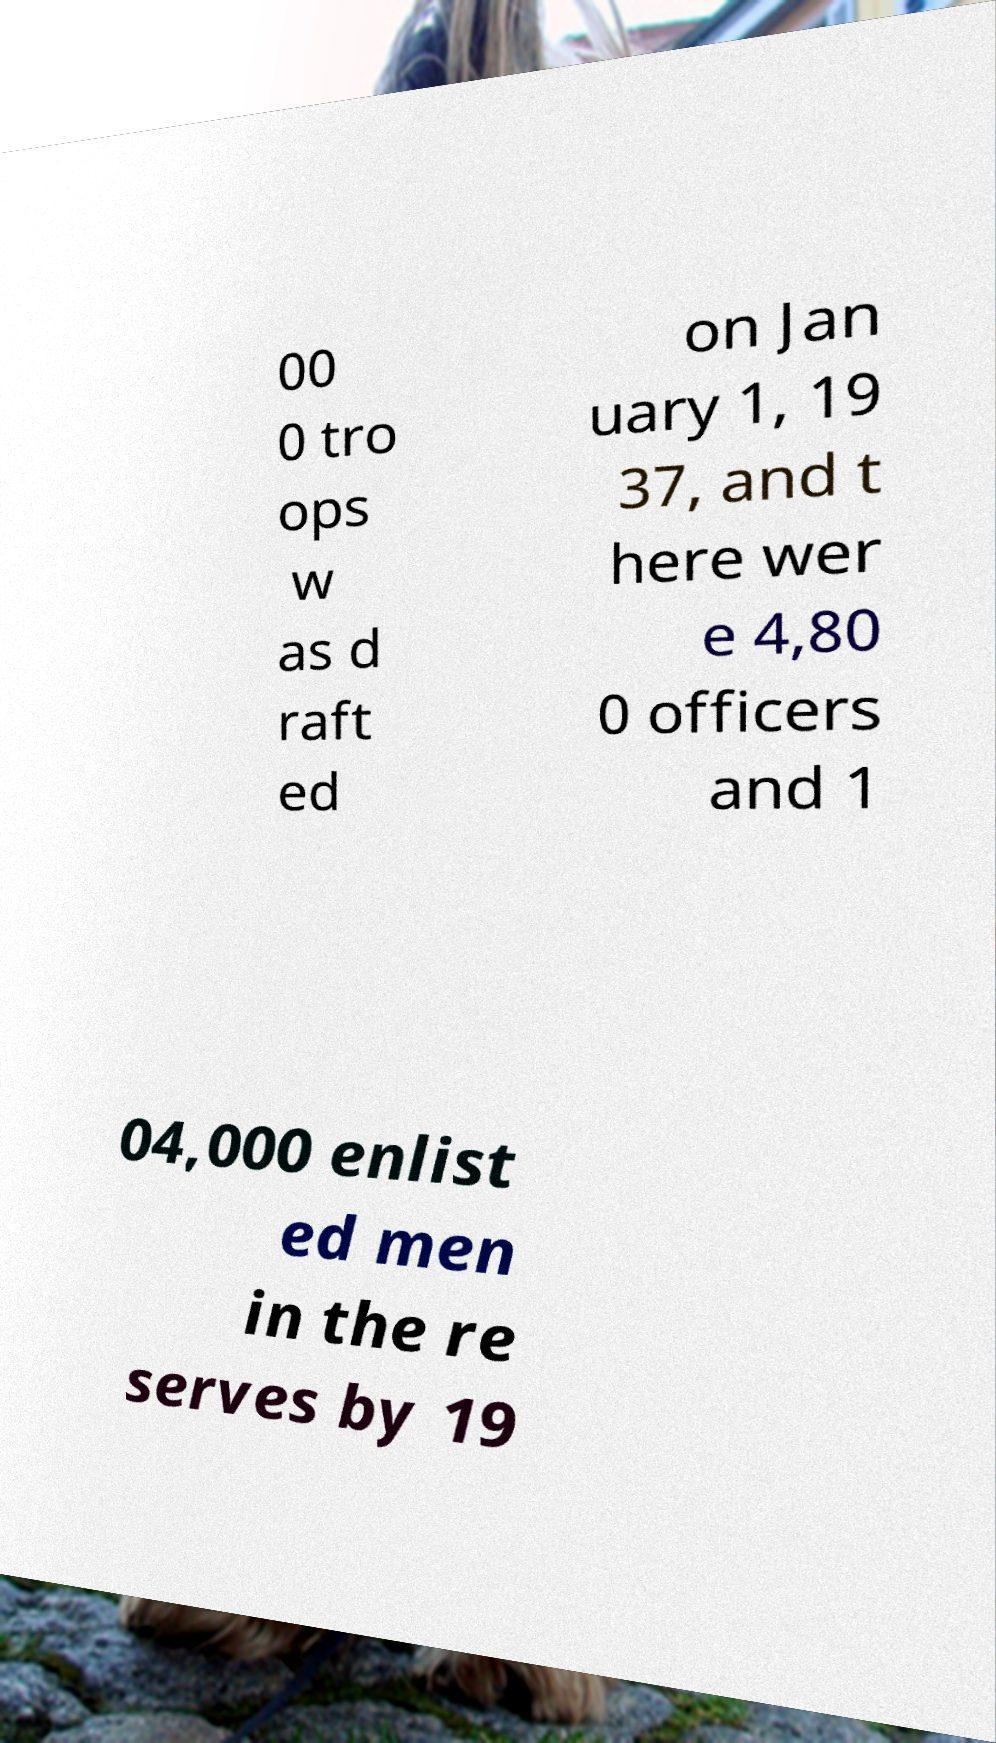For documentation purposes, I need the text within this image transcribed. Could you provide that? 00 0 tro ops w as d raft ed on Jan uary 1, 19 37, and t here wer e 4,80 0 officers and 1 04,000 enlist ed men in the re serves by 19 